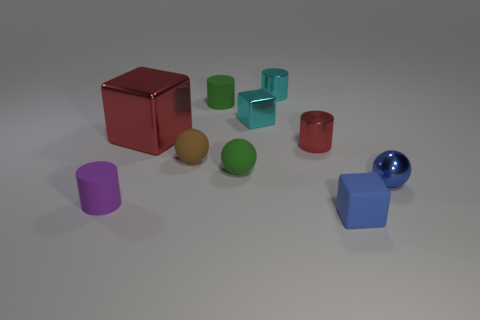Is there anything else that has the same material as the red cylinder?
Your response must be concise. Yes. What number of spheres are green things or tiny metallic things?
Keep it short and to the point. 2. Is the size of the cylinder in front of the small blue sphere the same as the blue rubber thing right of the green matte sphere?
Provide a succinct answer. Yes. There is a blue thing on the left side of the object right of the tiny blue rubber block; what is its material?
Your answer should be compact. Rubber. Is the number of red shiny cubes that are behind the small cyan cube less than the number of cyan blocks?
Provide a succinct answer. Yes. There is a purple thing that is made of the same material as the tiny brown thing; what is its shape?
Give a very brief answer. Cylinder. How many other objects are there of the same shape as the small red thing?
Make the answer very short. 3. What number of blue things are either blocks or metal objects?
Your answer should be very brief. 2. Is the purple matte object the same shape as the tiny red shiny thing?
Make the answer very short. Yes. There is a rubber thing that is behind the large object; is there a small cyan thing right of it?
Your answer should be very brief. Yes. 